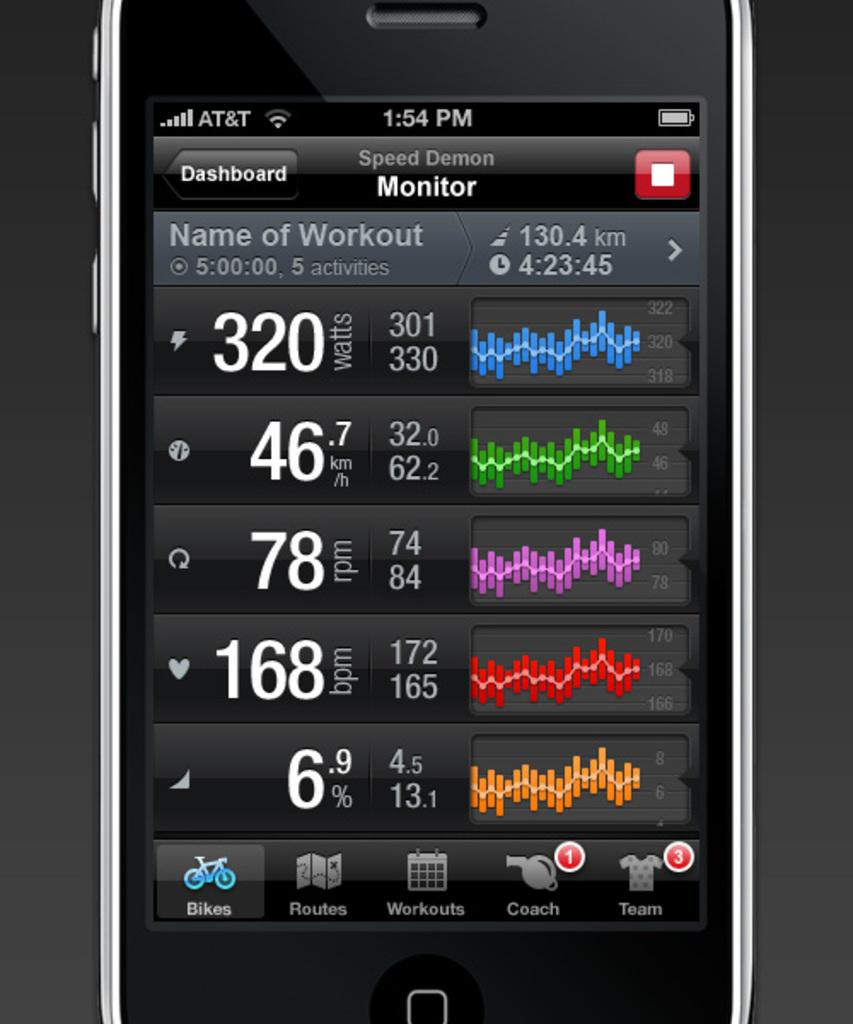What electronic device is visible in the image? There is a mobile phone in the image. What is displayed on the mobile phone screen? The mobile phone screen displays a dashboard. How much money is being discussed in the meeting shown on the mobile phone screen? There is no meeting or discussion of money shown on the mobile phone screen; it displays a dashboard. 